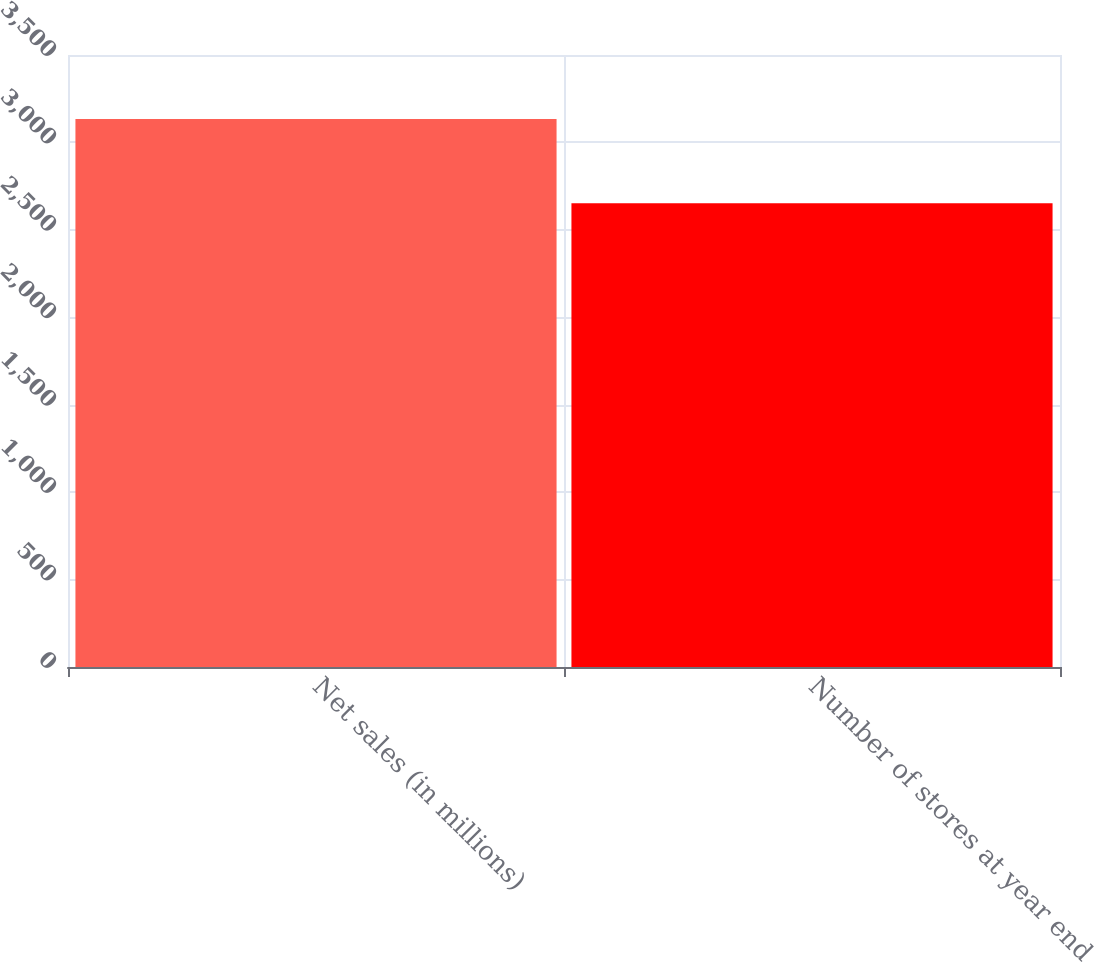Convert chart. <chart><loc_0><loc_0><loc_500><loc_500><bar_chart><fcel>Net sales (in millions)<fcel>Number of stores at year end<nl><fcel>3133.6<fcel>2652<nl></chart> 